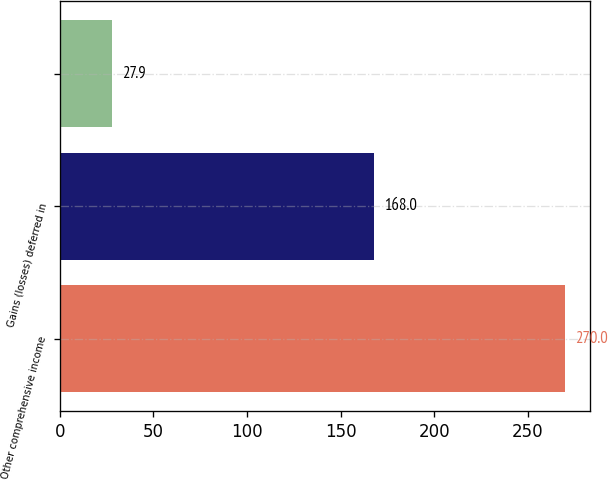<chart> <loc_0><loc_0><loc_500><loc_500><bar_chart><fcel>Other comprehensive income<fcel>Gains (losses) deferred in<fcel>Unnamed: 2<nl><fcel>270<fcel>168<fcel>27.9<nl></chart> 